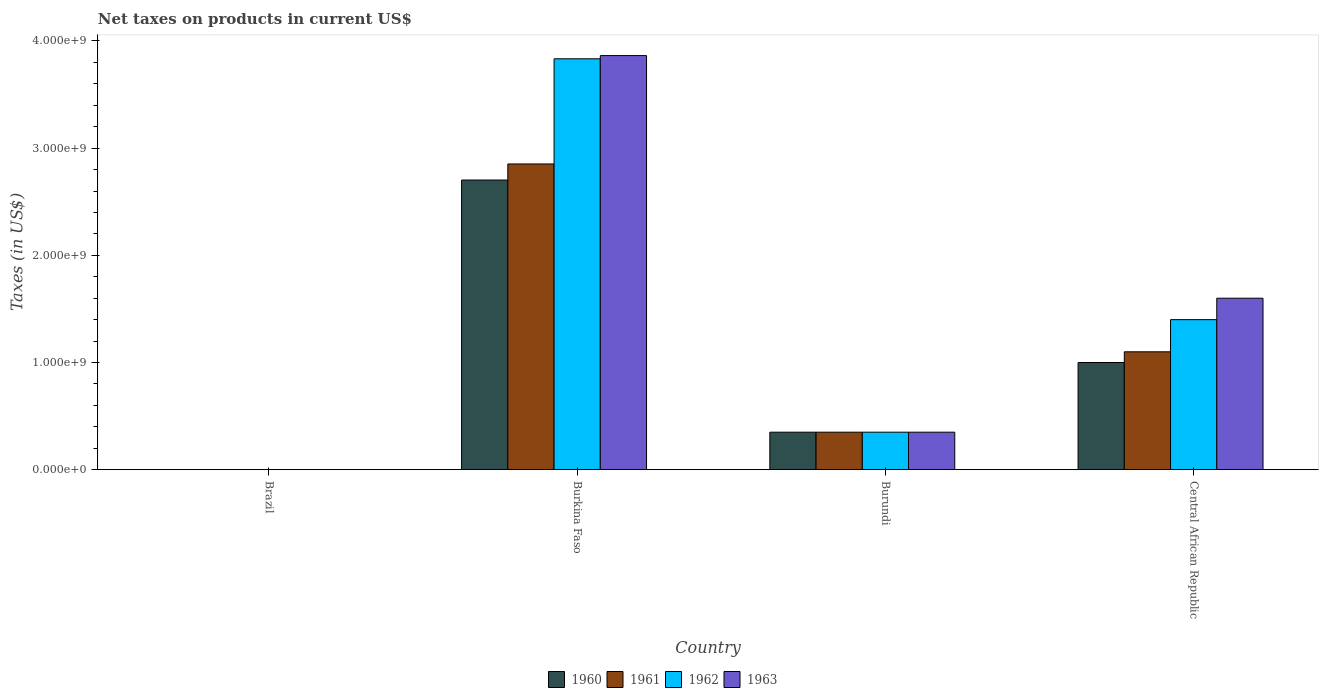How many different coloured bars are there?
Your answer should be very brief. 4. How many groups of bars are there?
Your response must be concise. 4. Are the number of bars on each tick of the X-axis equal?
Offer a terse response. Yes. How many bars are there on the 1st tick from the left?
Your answer should be very brief. 4. How many bars are there on the 2nd tick from the right?
Your response must be concise. 4. What is the label of the 4th group of bars from the left?
Offer a very short reply. Central African Republic. What is the net taxes on products in 1962 in Burkina Faso?
Give a very brief answer. 3.83e+09. Across all countries, what is the maximum net taxes on products in 1962?
Offer a terse response. 3.83e+09. Across all countries, what is the minimum net taxes on products in 1960?
Your answer should be very brief. 0. In which country was the net taxes on products in 1960 maximum?
Your answer should be compact. Burkina Faso. In which country was the net taxes on products in 1963 minimum?
Ensure brevity in your answer.  Brazil. What is the total net taxes on products in 1960 in the graph?
Ensure brevity in your answer.  4.05e+09. What is the difference between the net taxes on products in 1963 in Burkina Faso and that in Burundi?
Give a very brief answer. 3.51e+09. What is the difference between the net taxes on products in 1962 in Central African Republic and the net taxes on products in 1961 in Brazil?
Make the answer very short. 1.40e+09. What is the average net taxes on products in 1960 per country?
Provide a short and direct response. 1.01e+09. What is the difference between the net taxes on products of/in 1961 and net taxes on products of/in 1960 in Burkina Faso?
Offer a terse response. 1.50e+08. In how many countries, is the net taxes on products in 1960 greater than 2000000000 US$?
Your answer should be very brief. 1. What is the ratio of the net taxes on products in 1961 in Burkina Faso to that in Burundi?
Keep it short and to the point. 8.15. What is the difference between the highest and the second highest net taxes on products in 1961?
Make the answer very short. 1.75e+09. What is the difference between the highest and the lowest net taxes on products in 1961?
Offer a terse response. 2.85e+09. Is it the case that in every country, the sum of the net taxes on products in 1963 and net taxes on products in 1961 is greater than the sum of net taxes on products in 1960 and net taxes on products in 1962?
Give a very brief answer. No. What does the 1st bar from the right in Burundi represents?
Offer a terse response. 1963. Is it the case that in every country, the sum of the net taxes on products in 1961 and net taxes on products in 1962 is greater than the net taxes on products in 1963?
Make the answer very short. No. Does the graph contain any zero values?
Your answer should be compact. No. Does the graph contain grids?
Keep it short and to the point. No. Where does the legend appear in the graph?
Your answer should be very brief. Bottom center. How many legend labels are there?
Ensure brevity in your answer.  4. How are the legend labels stacked?
Offer a very short reply. Horizontal. What is the title of the graph?
Provide a short and direct response. Net taxes on products in current US$. Does "1998" appear as one of the legend labels in the graph?
Offer a terse response. No. What is the label or title of the Y-axis?
Offer a terse response. Taxes (in US$). What is the Taxes (in US$) of 1960 in Brazil?
Give a very brief answer. 0. What is the Taxes (in US$) in 1961 in Brazil?
Your answer should be very brief. 0. What is the Taxes (in US$) of 1962 in Brazil?
Your response must be concise. 0. What is the Taxes (in US$) in 1963 in Brazil?
Make the answer very short. 0. What is the Taxes (in US$) of 1960 in Burkina Faso?
Keep it short and to the point. 2.70e+09. What is the Taxes (in US$) in 1961 in Burkina Faso?
Your answer should be very brief. 2.85e+09. What is the Taxes (in US$) in 1962 in Burkina Faso?
Your answer should be compact. 3.83e+09. What is the Taxes (in US$) in 1963 in Burkina Faso?
Ensure brevity in your answer.  3.86e+09. What is the Taxes (in US$) of 1960 in Burundi?
Provide a short and direct response. 3.50e+08. What is the Taxes (in US$) of 1961 in Burundi?
Offer a terse response. 3.50e+08. What is the Taxes (in US$) in 1962 in Burundi?
Provide a short and direct response. 3.50e+08. What is the Taxes (in US$) in 1963 in Burundi?
Offer a very short reply. 3.50e+08. What is the Taxes (in US$) of 1960 in Central African Republic?
Your answer should be very brief. 1.00e+09. What is the Taxes (in US$) in 1961 in Central African Republic?
Your answer should be very brief. 1.10e+09. What is the Taxes (in US$) of 1962 in Central African Republic?
Keep it short and to the point. 1.40e+09. What is the Taxes (in US$) in 1963 in Central African Republic?
Give a very brief answer. 1.60e+09. Across all countries, what is the maximum Taxes (in US$) of 1960?
Provide a short and direct response. 2.70e+09. Across all countries, what is the maximum Taxes (in US$) in 1961?
Offer a terse response. 2.85e+09. Across all countries, what is the maximum Taxes (in US$) in 1962?
Give a very brief answer. 3.83e+09. Across all countries, what is the maximum Taxes (in US$) of 1963?
Your response must be concise. 3.86e+09. Across all countries, what is the minimum Taxes (in US$) of 1960?
Provide a short and direct response. 0. Across all countries, what is the minimum Taxes (in US$) in 1961?
Make the answer very short. 0. Across all countries, what is the minimum Taxes (in US$) in 1962?
Your response must be concise. 0. Across all countries, what is the minimum Taxes (in US$) in 1963?
Make the answer very short. 0. What is the total Taxes (in US$) in 1960 in the graph?
Offer a terse response. 4.05e+09. What is the total Taxes (in US$) of 1961 in the graph?
Offer a very short reply. 4.30e+09. What is the total Taxes (in US$) in 1962 in the graph?
Ensure brevity in your answer.  5.58e+09. What is the total Taxes (in US$) of 1963 in the graph?
Your answer should be very brief. 5.81e+09. What is the difference between the Taxes (in US$) in 1960 in Brazil and that in Burkina Faso?
Give a very brief answer. -2.70e+09. What is the difference between the Taxes (in US$) of 1961 in Brazil and that in Burkina Faso?
Keep it short and to the point. -2.85e+09. What is the difference between the Taxes (in US$) of 1962 in Brazil and that in Burkina Faso?
Offer a very short reply. -3.83e+09. What is the difference between the Taxes (in US$) in 1963 in Brazil and that in Burkina Faso?
Your response must be concise. -3.86e+09. What is the difference between the Taxes (in US$) of 1960 in Brazil and that in Burundi?
Provide a succinct answer. -3.50e+08. What is the difference between the Taxes (in US$) of 1961 in Brazil and that in Burundi?
Make the answer very short. -3.50e+08. What is the difference between the Taxes (in US$) in 1962 in Brazil and that in Burundi?
Offer a terse response. -3.50e+08. What is the difference between the Taxes (in US$) of 1963 in Brazil and that in Burundi?
Offer a terse response. -3.50e+08. What is the difference between the Taxes (in US$) of 1960 in Brazil and that in Central African Republic?
Provide a short and direct response. -1.00e+09. What is the difference between the Taxes (in US$) of 1961 in Brazil and that in Central African Republic?
Offer a very short reply. -1.10e+09. What is the difference between the Taxes (in US$) in 1962 in Brazil and that in Central African Republic?
Provide a succinct answer. -1.40e+09. What is the difference between the Taxes (in US$) of 1963 in Brazil and that in Central African Republic?
Offer a terse response. -1.60e+09. What is the difference between the Taxes (in US$) in 1960 in Burkina Faso and that in Burundi?
Offer a very short reply. 2.35e+09. What is the difference between the Taxes (in US$) in 1961 in Burkina Faso and that in Burundi?
Your answer should be very brief. 2.50e+09. What is the difference between the Taxes (in US$) in 1962 in Burkina Faso and that in Burundi?
Your answer should be very brief. 3.48e+09. What is the difference between the Taxes (in US$) in 1963 in Burkina Faso and that in Burundi?
Ensure brevity in your answer.  3.51e+09. What is the difference between the Taxes (in US$) of 1960 in Burkina Faso and that in Central African Republic?
Provide a short and direct response. 1.70e+09. What is the difference between the Taxes (in US$) in 1961 in Burkina Faso and that in Central African Republic?
Keep it short and to the point. 1.75e+09. What is the difference between the Taxes (in US$) of 1962 in Burkina Faso and that in Central African Republic?
Offer a very short reply. 2.43e+09. What is the difference between the Taxes (in US$) in 1963 in Burkina Faso and that in Central African Republic?
Offer a terse response. 2.26e+09. What is the difference between the Taxes (in US$) of 1960 in Burundi and that in Central African Republic?
Your response must be concise. -6.50e+08. What is the difference between the Taxes (in US$) of 1961 in Burundi and that in Central African Republic?
Your answer should be compact. -7.50e+08. What is the difference between the Taxes (in US$) of 1962 in Burundi and that in Central African Republic?
Provide a short and direct response. -1.05e+09. What is the difference between the Taxes (in US$) in 1963 in Burundi and that in Central African Republic?
Your answer should be very brief. -1.25e+09. What is the difference between the Taxes (in US$) of 1960 in Brazil and the Taxes (in US$) of 1961 in Burkina Faso?
Your answer should be compact. -2.85e+09. What is the difference between the Taxes (in US$) in 1960 in Brazil and the Taxes (in US$) in 1962 in Burkina Faso?
Offer a terse response. -3.83e+09. What is the difference between the Taxes (in US$) in 1960 in Brazil and the Taxes (in US$) in 1963 in Burkina Faso?
Offer a terse response. -3.86e+09. What is the difference between the Taxes (in US$) of 1961 in Brazil and the Taxes (in US$) of 1962 in Burkina Faso?
Ensure brevity in your answer.  -3.83e+09. What is the difference between the Taxes (in US$) of 1961 in Brazil and the Taxes (in US$) of 1963 in Burkina Faso?
Your answer should be very brief. -3.86e+09. What is the difference between the Taxes (in US$) in 1962 in Brazil and the Taxes (in US$) in 1963 in Burkina Faso?
Offer a very short reply. -3.86e+09. What is the difference between the Taxes (in US$) of 1960 in Brazil and the Taxes (in US$) of 1961 in Burundi?
Provide a succinct answer. -3.50e+08. What is the difference between the Taxes (in US$) of 1960 in Brazil and the Taxes (in US$) of 1962 in Burundi?
Keep it short and to the point. -3.50e+08. What is the difference between the Taxes (in US$) in 1960 in Brazil and the Taxes (in US$) in 1963 in Burundi?
Offer a very short reply. -3.50e+08. What is the difference between the Taxes (in US$) of 1961 in Brazil and the Taxes (in US$) of 1962 in Burundi?
Provide a succinct answer. -3.50e+08. What is the difference between the Taxes (in US$) in 1961 in Brazil and the Taxes (in US$) in 1963 in Burundi?
Ensure brevity in your answer.  -3.50e+08. What is the difference between the Taxes (in US$) of 1962 in Brazil and the Taxes (in US$) of 1963 in Burundi?
Provide a succinct answer. -3.50e+08. What is the difference between the Taxes (in US$) of 1960 in Brazil and the Taxes (in US$) of 1961 in Central African Republic?
Offer a terse response. -1.10e+09. What is the difference between the Taxes (in US$) in 1960 in Brazil and the Taxes (in US$) in 1962 in Central African Republic?
Keep it short and to the point. -1.40e+09. What is the difference between the Taxes (in US$) in 1960 in Brazil and the Taxes (in US$) in 1963 in Central African Republic?
Your answer should be very brief. -1.60e+09. What is the difference between the Taxes (in US$) of 1961 in Brazil and the Taxes (in US$) of 1962 in Central African Republic?
Make the answer very short. -1.40e+09. What is the difference between the Taxes (in US$) of 1961 in Brazil and the Taxes (in US$) of 1963 in Central African Republic?
Your answer should be very brief. -1.60e+09. What is the difference between the Taxes (in US$) in 1962 in Brazil and the Taxes (in US$) in 1963 in Central African Republic?
Provide a succinct answer. -1.60e+09. What is the difference between the Taxes (in US$) of 1960 in Burkina Faso and the Taxes (in US$) of 1961 in Burundi?
Give a very brief answer. 2.35e+09. What is the difference between the Taxes (in US$) of 1960 in Burkina Faso and the Taxes (in US$) of 1962 in Burundi?
Ensure brevity in your answer.  2.35e+09. What is the difference between the Taxes (in US$) of 1960 in Burkina Faso and the Taxes (in US$) of 1963 in Burundi?
Make the answer very short. 2.35e+09. What is the difference between the Taxes (in US$) of 1961 in Burkina Faso and the Taxes (in US$) of 1962 in Burundi?
Your answer should be compact. 2.50e+09. What is the difference between the Taxes (in US$) in 1961 in Burkina Faso and the Taxes (in US$) in 1963 in Burundi?
Offer a very short reply. 2.50e+09. What is the difference between the Taxes (in US$) in 1962 in Burkina Faso and the Taxes (in US$) in 1963 in Burundi?
Offer a terse response. 3.48e+09. What is the difference between the Taxes (in US$) of 1960 in Burkina Faso and the Taxes (in US$) of 1961 in Central African Republic?
Offer a very short reply. 1.60e+09. What is the difference between the Taxes (in US$) of 1960 in Burkina Faso and the Taxes (in US$) of 1962 in Central African Republic?
Provide a short and direct response. 1.30e+09. What is the difference between the Taxes (in US$) in 1960 in Burkina Faso and the Taxes (in US$) in 1963 in Central African Republic?
Provide a succinct answer. 1.10e+09. What is the difference between the Taxes (in US$) in 1961 in Burkina Faso and the Taxes (in US$) in 1962 in Central African Republic?
Your answer should be compact. 1.45e+09. What is the difference between the Taxes (in US$) in 1961 in Burkina Faso and the Taxes (in US$) in 1963 in Central African Republic?
Your response must be concise. 1.25e+09. What is the difference between the Taxes (in US$) in 1962 in Burkina Faso and the Taxes (in US$) in 1963 in Central African Republic?
Give a very brief answer. 2.23e+09. What is the difference between the Taxes (in US$) of 1960 in Burundi and the Taxes (in US$) of 1961 in Central African Republic?
Offer a terse response. -7.50e+08. What is the difference between the Taxes (in US$) in 1960 in Burundi and the Taxes (in US$) in 1962 in Central African Republic?
Your answer should be very brief. -1.05e+09. What is the difference between the Taxes (in US$) of 1960 in Burundi and the Taxes (in US$) of 1963 in Central African Republic?
Your answer should be very brief. -1.25e+09. What is the difference between the Taxes (in US$) in 1961 in Burundi and the Taxes (in US$) in 1962 in Central African Republic?
Your response must be concise. -1.05e+09. What is the difference between the Taxes (in US$) of 1961 in Burundi and the Taxes (in US$) of 1963 in Central African Republic?
Make the answer very short. -1.25e+09. What is the difference between the Taxes (in US$) of 1962 in Burundi and the Taxes (in US$) of 1963 in Central African Republic?
Offer a very short reply. -1.25e+09. What is the average Taxes (in US$) of 1960 per country?
Make the answer very short. 1.01e+09. What is the average Taxes (in US$) in 1961 per country?
Provide a succinct answer. 1.08e+09. What is the average Taxes (in US$) of 1962 per country?
Provide a short and direct response. 1.40e+09. What is the average Taxes (in US$) in 1963 per country?
Provide a succinct answer. 1.45e+09. What is the difference between the Taxes (in US$) in 1960 and Taxes (in US$) in 1961 in Brazil?
Offer a very short reply. -0. What is the difference between the Taxes (in US$) of 1960 and Taxes (in US$) of 1962 in Brazil?
Provide a short and direct response. -0. What is the difference between the Taxes (in US$) in 1960 and Taxes (in US$) in 1963 in Brazil?
Provide a short and direct response. -0. What is the difference between the Taxes (in US$) of 1961 and Taxes (in US$) of 1962 in Brazil?
Make the answer very short. -0. What is the difference between the Taxes (in US$) of 1961 and Taxes (in US$) of 1963 in Brazil?
Offer a very short reply. -0. What is the difference between the Taxes (in US$) in 1962 and Taxes (in US$) in 1963 in Brazil?
Your answer should be compact. -0. What is the difference between the Taxes (in US$) in 1960 and Taxes (in US$) in 1961 in Burkina Faso?
Your answer should be compact. -1.50e+08. What is the difference between the Taxes (in US$) in 1960 and Taxes (in US$) in 1962 in Burkina Faso?
Your response must be concise. -1.13e+09. What is the difference between the Taxes (in US$) of 1960 and Taxes (in US$) of 1963 in Burkina Faso?
Your answer should be compact. -1.16e+09. What is the difference between the Taxes (in US$) in 1961 and Taxes (in US$) in 1962 in Burkina Faso?
Make the answer very short. -9.81e+08. What is the difference between the Taxes (in US$) in 1961 and Taxes (in US$) in 1963 in Burkina Faso?
Keep it short and to the point. -1.01e+09. What is the difference between the Taxes (in US$) of 1962 and Taxes (in US$) of 1963 in Burkina Faso?
Your answer should be very brief. -3.00e+07. What is the difference between the Taxes (in US$) of 1960 and Taxes (in US$) of 1961 in Burundi?
Your answer should be compact. 0. What is the difference between the Taxes (in US$) in 1961 and Taxes (in US$) in 1963 in Burundi?
Keep it short and to the point. 0. What is the difference between the Taxes (in US$) in 1962 and Taxes (in US$) in 1963 in Burundi?
Make the answer very short. 0. What is the difference between the Taxes (in US$) of 1960 and Taxes (in US$) of 1961 in Central African Republic?
Your answer should be compact. -1.00e+08. What is the difference between the Taxes (in US$) of 1960 and Taxes (in US$) of 1962 in Central African Republic?
Make the answer very short. -4.00e+08. What is the difference between the Taxes (in US$) in 1960 and Taxes (in US$) in 1963 in Central African Republic?
Provide a short and direct response. -6.00e+08. What is the difference between the Taxes (in US$) of 1961 and Taxes (in US$) of 1962 in Central African Republic?
Provide a succinct answer. -3.00e+08. What is the difference between the Taxes (in US$) in 1961 and Taxes (in US$) in 1963 in Central African Republic?
Offer a terse response. -5.00e+08. What is the difference between the Taxes (in US$) in 1962 and Taxes (in US$) in 1963 in Central African Republic?
Ensure brevity in your answer.  -2.00e+08. What is the ratio of the Taxes (in US$) of 1961 in Brazil to that in Burkina Faso?
Your answer should be compact. 0. What is the ratio of the Taxes (in US$) in 1963 in Brazil to that in Burkina Faso?
Offer a terse response. 0. What is the ratio of the Taxes (in US$) of 1962 in Brazil to that in Burundi?
Your answer should be very brief. 0. What is the ratio of the Taxes (in US$) in 1963 in Brazil to that in Burundi?
Give a very brief answer. 0. What is the ratio of the Taxes (in US$) of 1960 in Brazil to that in Central African Republic?
Provide a short and direct response. 0. What is the ratio of the Taxes (in US$) of 1961 in Brazil to that in Central African Republic?
Provide a short and direct response. 0. What is the ratio of the Taxes (in US$) in 1962 in Brazil to that in Central African Republic?
Provide a short and direct response. 0. What is the ratio of the Taxes (in US$) of 1960 in Burkina Faso to that in Burundi?
Provide a succinct answer. 7.72. What is the ratio of the Taxes (in US$) in 1961 in Burkina Faso to that in Burundi?
Your response must be concise. 8.15. What is the ratio of the Taxes (in US$) in 1962 in Burkina Faso to that in Burundi?
Make the answer very short. 10.95. What is the ratio of the Taxes (in US$) in 1963 in Burkina Faso to that in Burundi?
Keep it short and to the point. 11.04. What is the ratio of the Taxes (in US$) in 1960 in Burkina Faso to that in Central African Republic?
Keep it short and to the point. 2.7. What is the ratio of the Taxes (in US$) of 1961 in Burkina Faso to that in Central African Republic?
Your response must be concise. 2.59. What is the ratio of the Taxes (in US$) in 1962 in Burkina Faso to that in Central African Republic?
Provide a short and direct response. 2.74. What is the ratio of the Taxes (in US$) of 1963 in Burkina Faso to that in Central African Republic?
Ensure brevity in your answer.  2.41. What is the ratio of the Taxes (in US$) in 1960 in Burundi to that in Central African Republic?
Make the answer very short. 0.35. What is the ratio of the Taxes (in US$) of 1961 in Burundi to that in Central African Republic?
Give a very brief answer. 0.32. What is the ratio of the Taxes (in US$) of 1962 in Burundi to that in Central African Republic?
Provide a short and direct response. 0.25. What is the ratio of the Taxes (in US$) in 1963 in Burundi to that in Central African Republic?
Your answer should be very brief. 0.22. What is the difference between the highest and the second highest Taxes (in US$) in 1960?
Give a very brief answer. 1.70e+09. What is the difference between the highest and the second highest Taxes (in US$) in 1961?
Make the answer very short. 1.75e+09. What is the difference between the highest and the second highest Taxes (in US$) of 1962?
Offer a very short reply. 2.43e+09. What is the difference between the highest and the second highest Taxes (in US$) of 1963?
Offer a very short reply. 2.26e+09. What is the difference between the highest and the lowest Taxes (in US$) of 1960?
Provide a succinct answer. 2.70e+09. What is the difference between the highest and the lowest Taxes (in US$) of 1961?
Make the answer very short. 2.85e+09. What is the difference between the highest and the lowest Taxes (in US$) of 1962?
Provide a succinct answer. 3.83e+09. What is the difference between the highest and the lowest Taxes (in US$) of 1963?
Offer a terse response. 3.86e+09. 